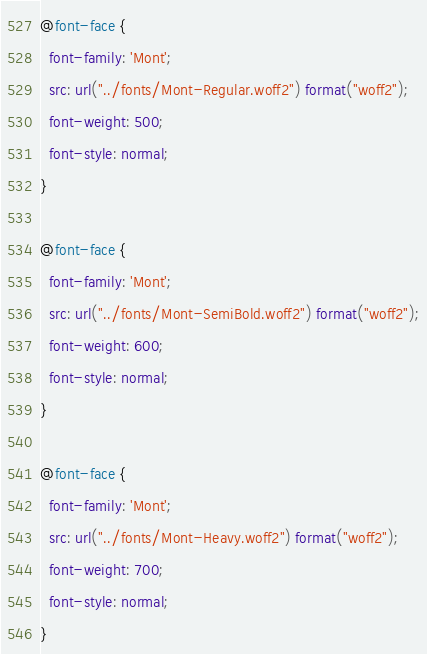Convert code to text. <code><loc_0><loc_0><loc_500><loc_500><_CSS_>@font-face {
  font-family: 'Mont';
  src: url("../fonts/Mont-Regular.woff2") format("woff2");
  font-weight: 500;
  font-style: normal;
}

@font-face {
  font-family: 'Mont';
  src: url("../fonts/Mont-SemiBold.woff2") format("woff2");
  font-weight: 600;
  font-style: normal;
}

@font-face {
  font-family: 'Mont';
  src: url("../fonts/Mont-Heavy.woff2") format("woff2");
  font-weight: 700;
  font-style: normal;
}</code> 